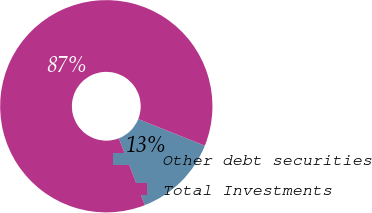Convert chart to OTSL. <chart><loc_0><loc_0><loc_500><loc_500><pie_chart><fcel>Other debt securities<fcel>Total Investments<nl><fcel>13.02%<fcel>86.98%<nl></chart> 